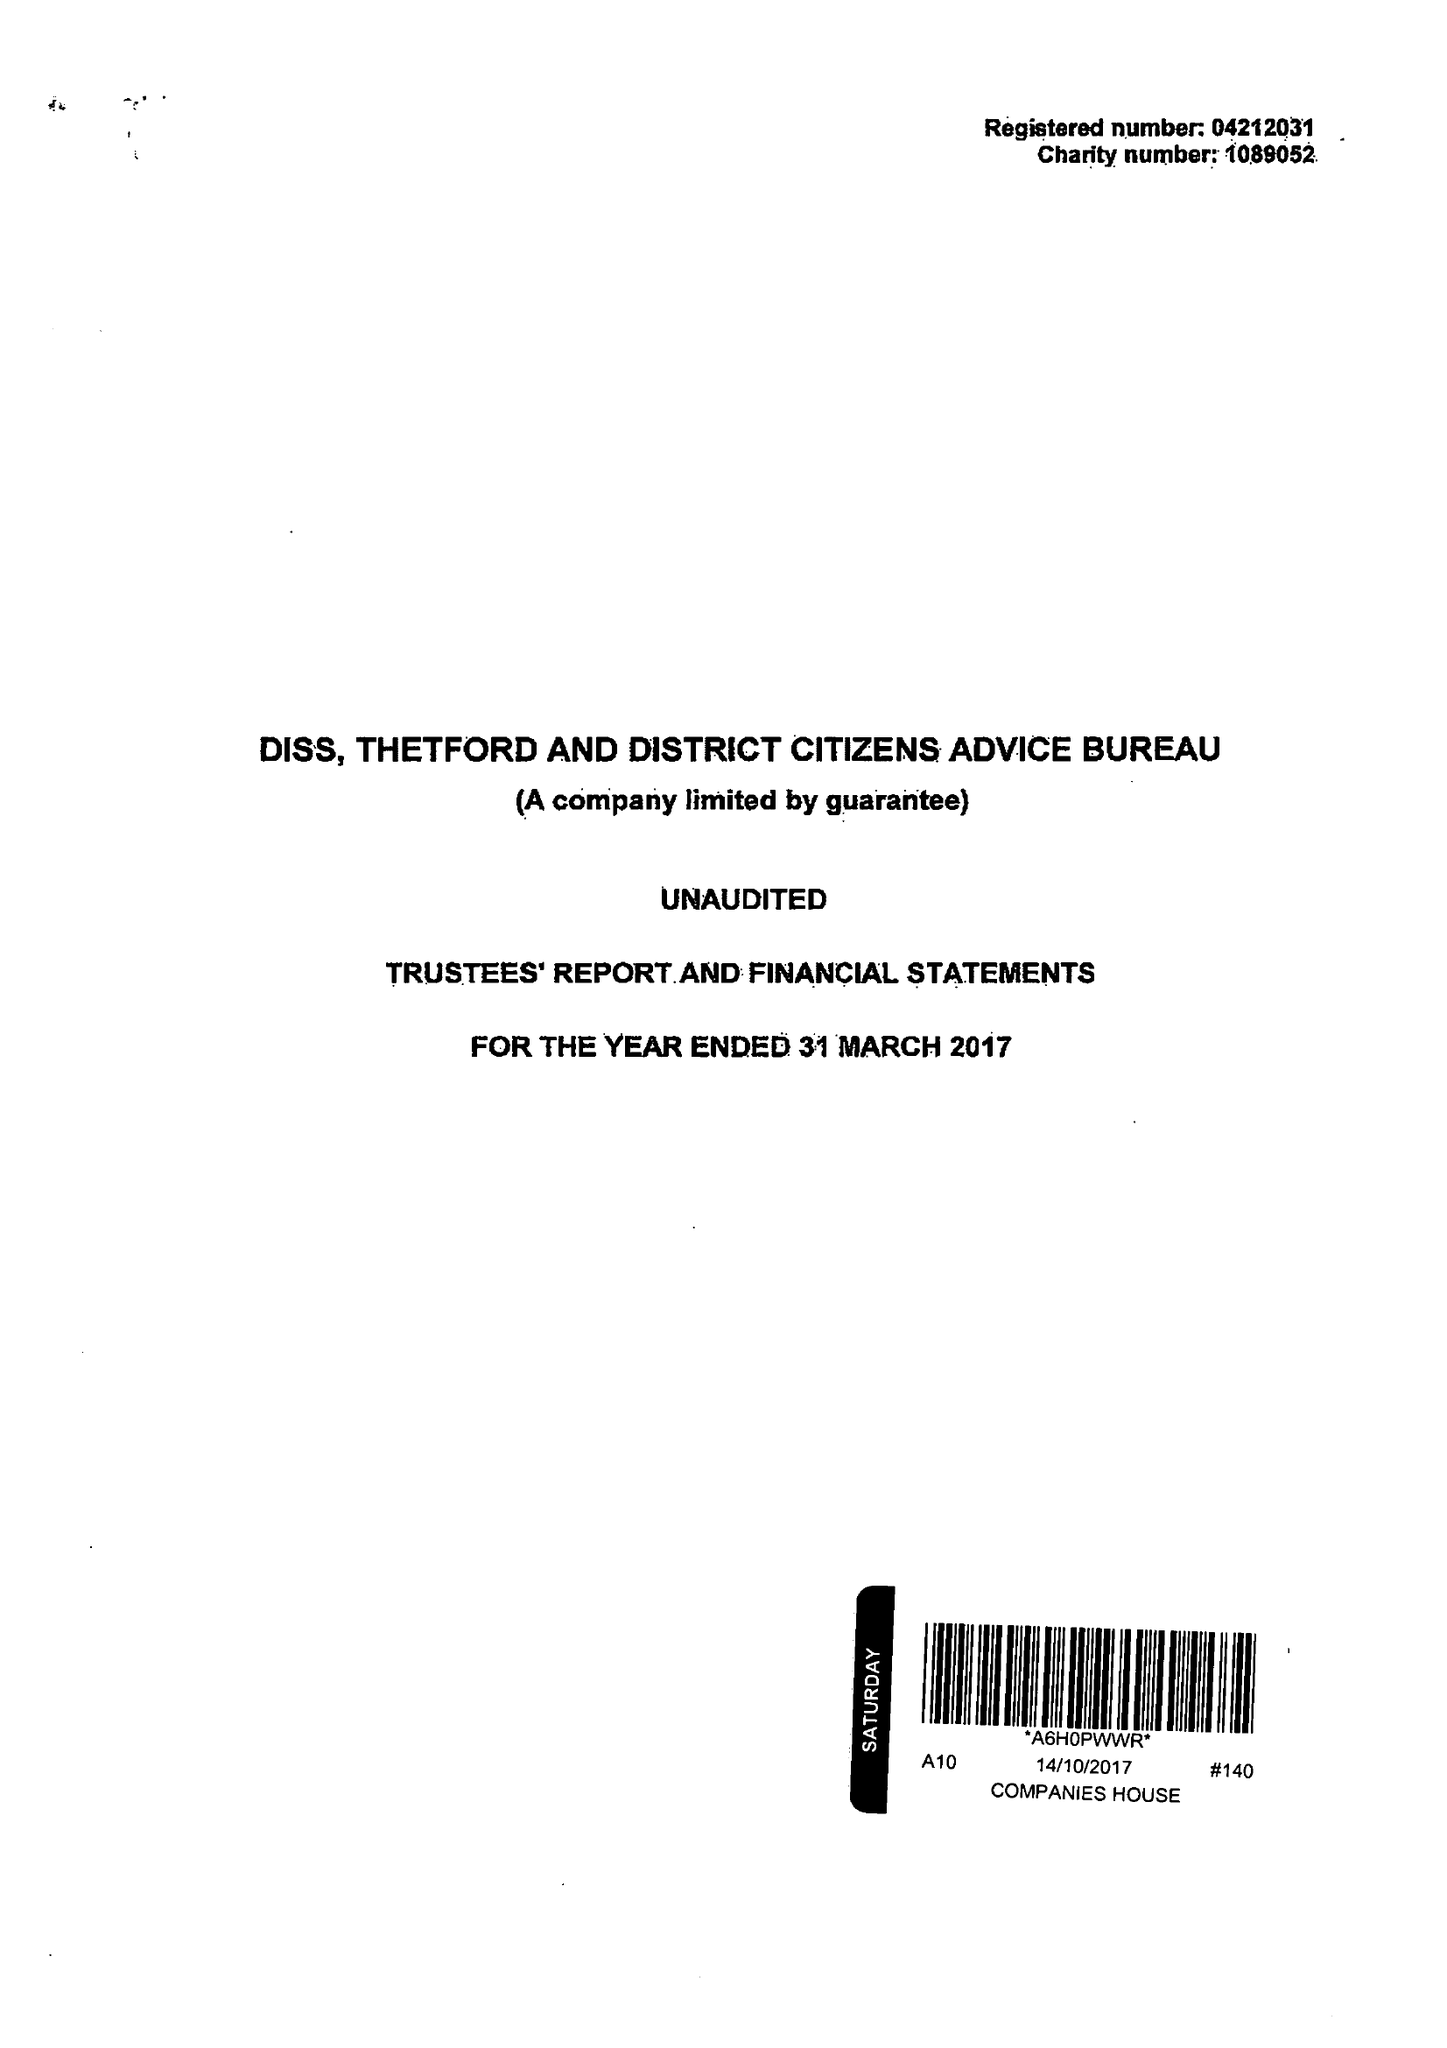What is the value for the report_date?
Answer the question using a single word or phrase. 2017-03-31 